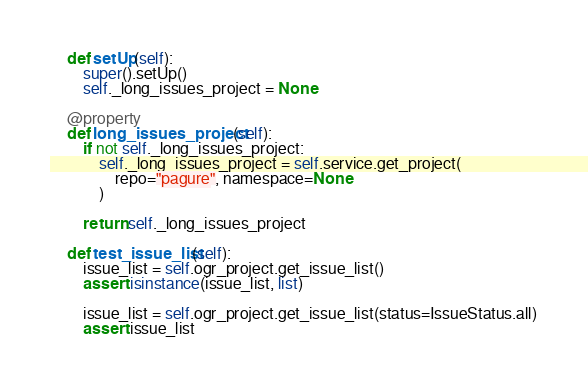<code> <loc_0><loc_0><loc_500><loc_500><_Python_>    def setUp(self):
        super().setUp()
        self._long_issues_project = None

    @property
    def long_issues_project(self):
        if not self._long_issues_project:
            self._long_issues_project = self.service.get_project(
                repo="pagure", namespace=None
            )

        return self._long_issues_project

    def test_issue_list(self):
        issue_list = self.ogr_project.get_issue_list()
        assert isinstance(issue_list, list)

        issue_list = self.ogr_project.get_issue_list(status=IssueStatus.all)
        assert issue_list</code> 